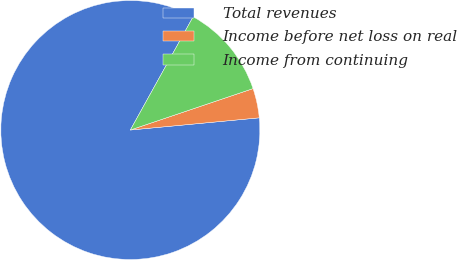Convert chart. <chart><loc_0><loc_0><loc_500><loc_500><pie_chart><fcel>Total revenues<fcel>Income before net loss on real<fcel>Income from continuing<nl><fcel>84.56%<fcel>3.68%<fcel>11.76%<nl></chart> 